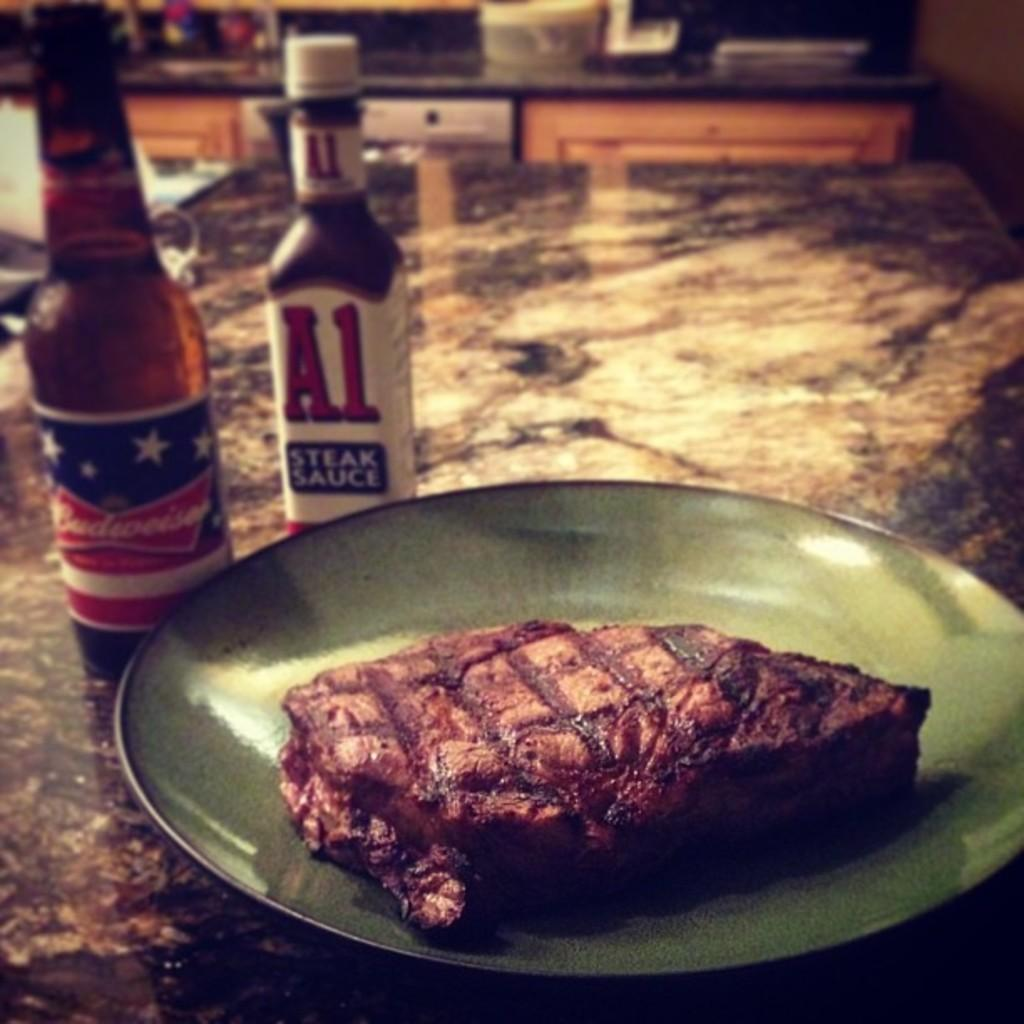What can be seen in the background of the image? There is a platform in the background of the image. What is on the platform? There is a box on the platform. What type of furniture is present in the image? There are desks in the image. What type of containers can be seen in the image? There are bottles visible in the image. What type of food is on the table in the image? There is a plate of meat on a table in the image. What is the price of the coach in the image? There is no coach present in the image, so it is not possible to determine its price. 